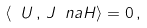Convert formula to latex. <formula><loc_0><loc_0><loc_500><loc_500>\langle \ U \, , \, J \ n a H \rangle = 0 \, ,</formula> 